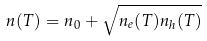<formula> <loc_0><loc_0><loc_500><loc_500>n ( T ) = n _ { 0 } + \sqrt { n _ { e } ( T ) n _ { h } ( T ) }</formula> 